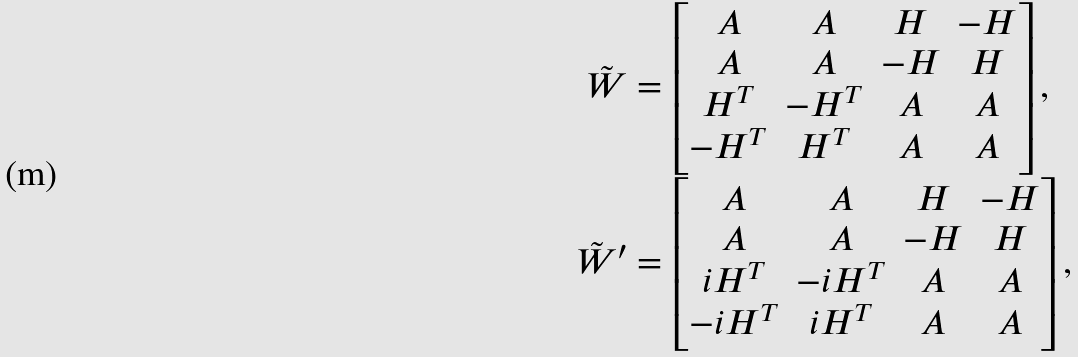Convert formula to latex. <formula><loc_0><loc_0><loc_500><loc_500>\tilde { W } & = \begin{bmatrix} A & A & H & - H \\ A & A & - H & H \\ H ^ { T } & - H ^ { T } & A & A \\ - H ^ { T } & H ^ { T } & A & A \end{bmatrix} , \\ \tilde { W } ^ { \prime } & = \begin{bmatrix} A & A & H & - H \\ A & A & - H & H \\ i H ^ { T } & - i H ^ { T } & A & A \\ - i H ^ { T } & i H ^ { T } & A & A \end{bmatrix} ,</formula> 